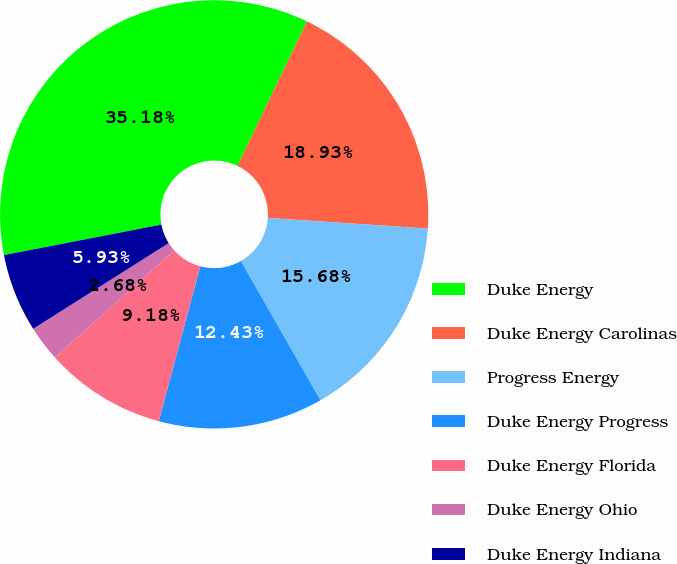Convert chart to OTSL. <chart><loc_0><loc_0><loc_500><loc_500><pie_chart><fcel>Duke Energy<fcel>Duke Energy Carolinas<fcel>Progress Energy<fcel>Duke Energy Progress<fcel>Duke Energy Florida<fcel>Duke Energy Ohio<fcel>Duke Energy Indiana<nl><fcel>35.18%<fcel>18.93%<fcel>15.68%<fcel>12.43%<fcel>9.18%<fcel>2.68%<fcel>5.93%<nl></chart> 